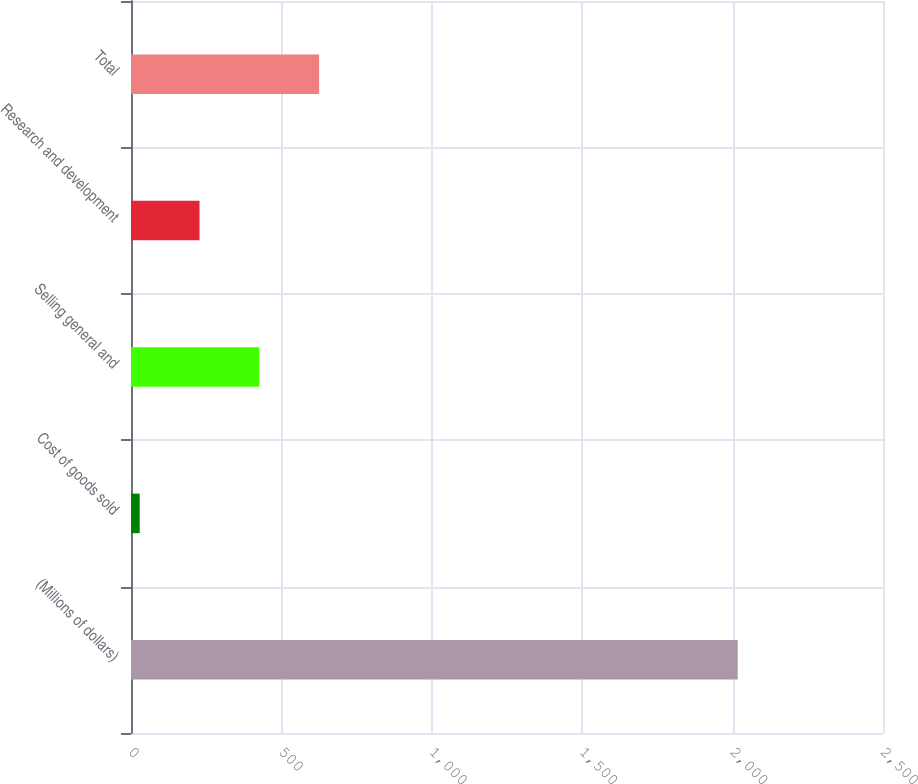Convert chart. <chart><loc_0><loc_0><loc_500><loc_500><bar_chart><fcel>(Millions of dollars)<fcel>Cost of goods sold<fcel>Selling general and<fcel>Research and development<fcel>Total<nl><fcel>2017<fcel>29<fcel>426.6<fcel>227.8<fcel>625.4<nl></chart> 